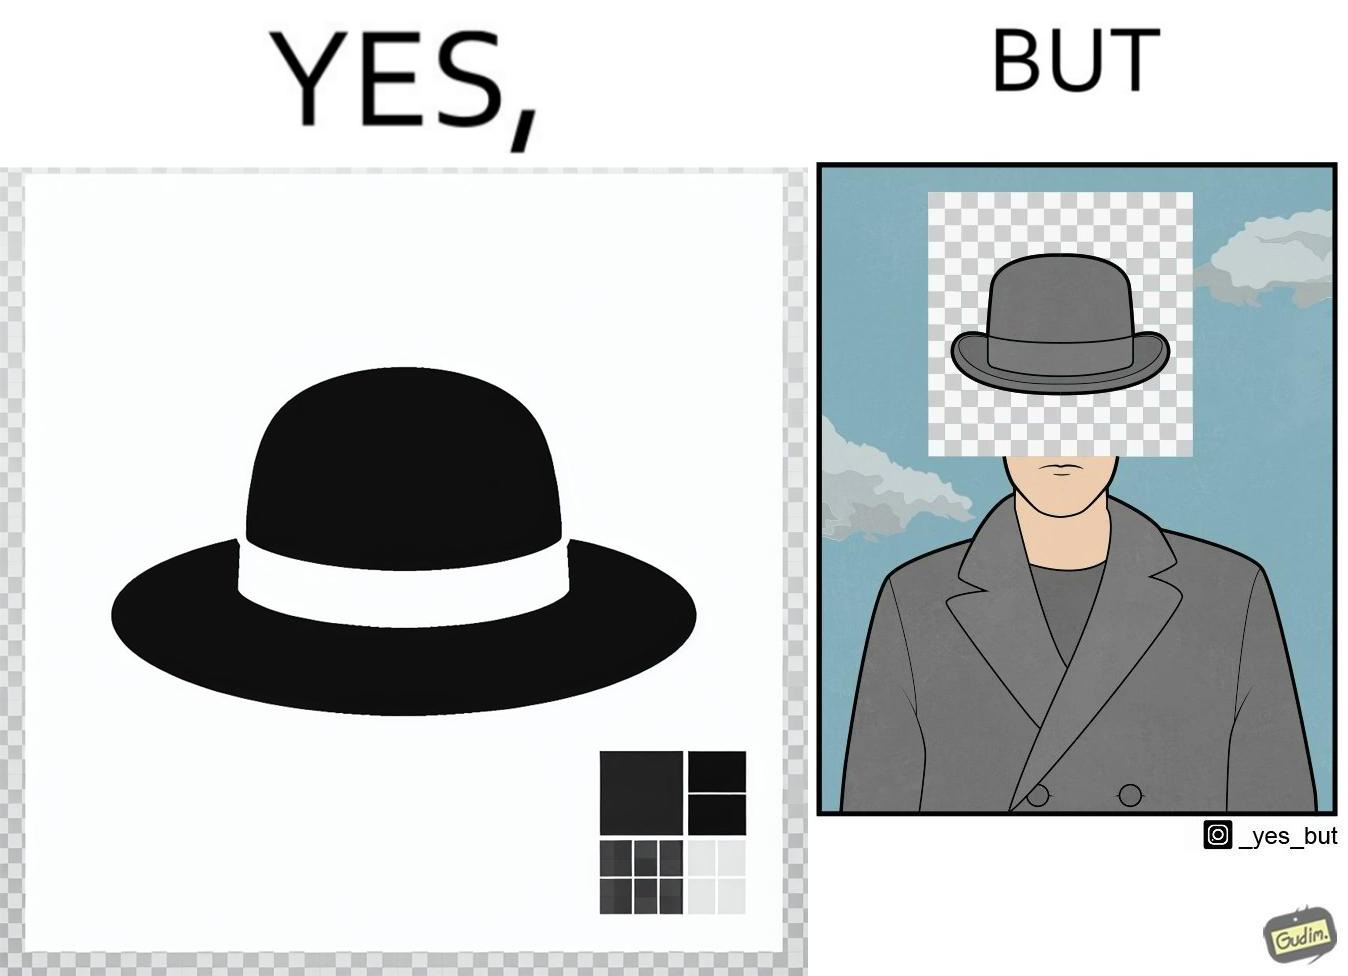What is shown in this image? The images are funny since the .png image of the hat is supposed to have a transparent background but when the image is used for editing a mans picture it is seen that the background is not actually transparent and it ends up covering the face of the man in the other picture. 